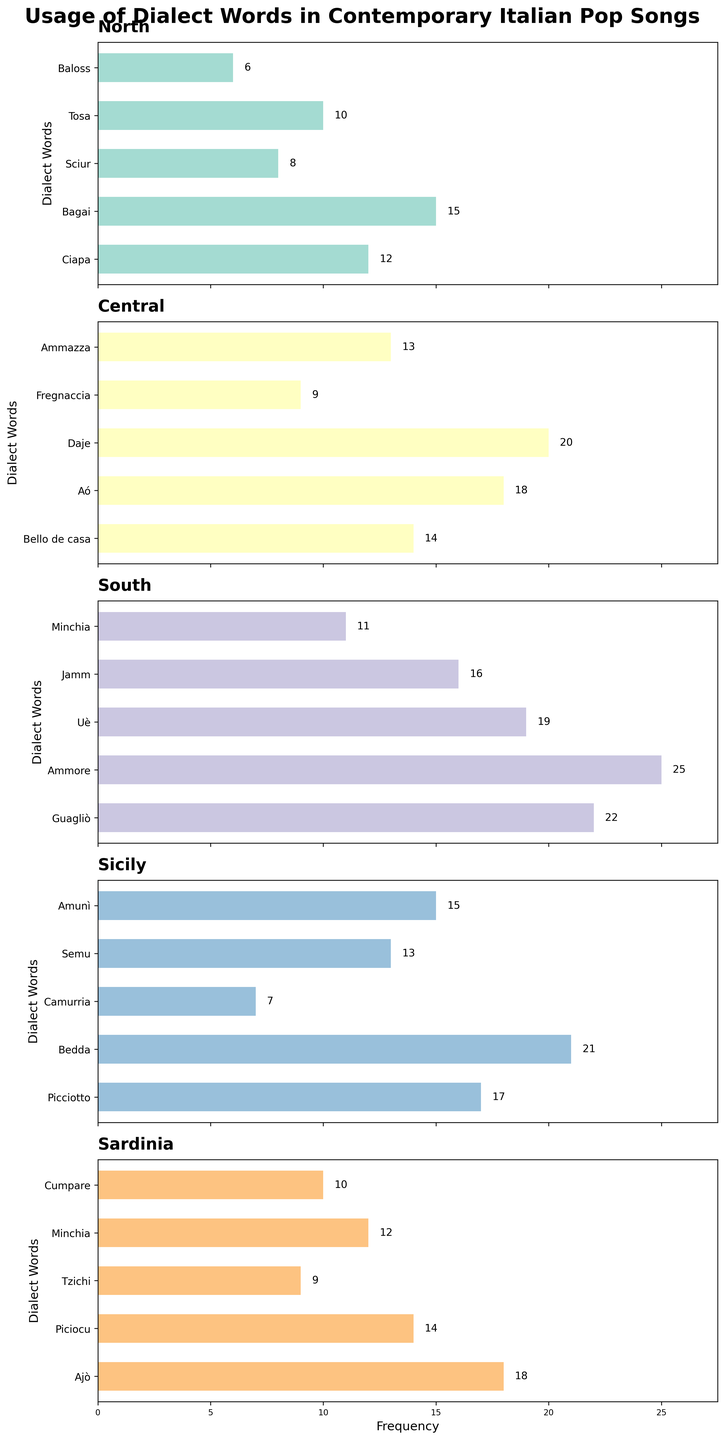Which region has the highest overall frequency of dialect words? To find this, you need to sum the frequencies of the dialect words for each region and then compare these sums. Summing up North: 12+15+8+10+6 = 51, Central: 14+18+20+9+13 = 74, South: 22+25+19+16+11 = 93, Sicily: 17+21+7+13+15 = 73, Sardinia: 18+14+9+12+10 = 63. The South has the highest overall frequency of 93.
Answer: South Which dialect word has the highest frequency in Central Italy? Look at the Central Italy subplot and identify the bar that extends the furthest to the right. "Daje" has the highest frequency of 20.
Answer: Daje Compare the frequency of 'Minchia' in South and Sardinia. Which is higher and by how much? Check the frequency of 'Minchia' in both regions. In the South, it's 11, and in Sardinia, it's 12. Thus, it is higher in Sardinia by 1.
Answer: Sardinia, by 1 What is the total frequency of the most common dialect words in each region? Identify the most common dialect word for each region and sum their frequencies: North: Bagai (15), Central: Daje (20), South: Ammore (25), Sicily: Bedda (21), Sardinia: Ajò (18). Summing these frequencies gives 15+20+25+21+18 = 99.
Answer: 99 Which region uses the word 'Minchia' and how often? Look at all the subplots and find which regions include the word 'Minchia'. It is found in South with a frequency of 11 and in Sardinia with a frequency of 12. Thus, both South and Sardinia use it, with frequencies 11 and 12 respectively.
Answer: Both South and Sardinia, 11 and 12 respectively What is the average frequency of dialect words in Sicily? Sum the frequencies of all the dialect words in Sicily and divide by the number of words. Sum: 17+21+7+13+15 = 73, Number of words: 5. Average frequency is 73/5 = 14.6.
Answer: 14.6 Which region uses the broadest variety of dialect words? Determine the number of unique dialect words per region and compare. Counting dialect words for each region: North (5), Central (5), South (5), Sicily (5), Sardinia (5). Each region uses 5 unique dialect words.
Answer: All regions use 5 What is the difference in frequency between the most common dialect word in North and the least common word in South? Identify the highest frequency in North (Bagai, 15) and the lowest in South (Minchia, 11). The difference is 15 - 11 = 4.
Answer: 4 